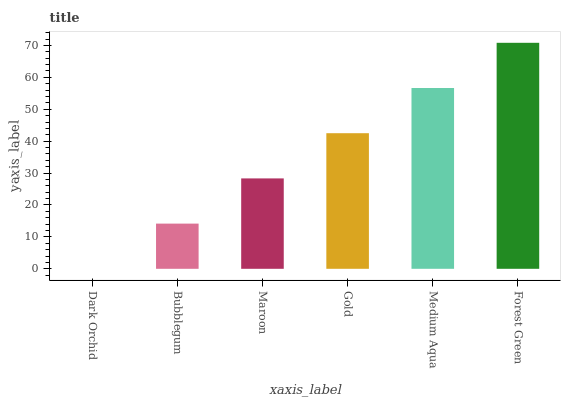Is Bubblegum the minimum?
Answer yes or no. No. Is Bubblegum the maximum?
Answer yes or no. No. Is Bubblegum greater than Dark Orchid?
Answer yes or no. Yes. Is Dark Orchid less than Bubblegum?
Answer yes or no. Yes. Is Dark Orchid greater than Bubblegum?
Answer yes or no. No. Is Bubblegum less than Dark Orchid?
Answer yes or no. No. Is Gold the high median?
Answer yes or no. Yes. Is Maroon the low median?
Answer yes or no. Yes. Is Bubblegum the high median?
Answer yes or no. No. Is Gold the low median?
Answer yes or no. No. 